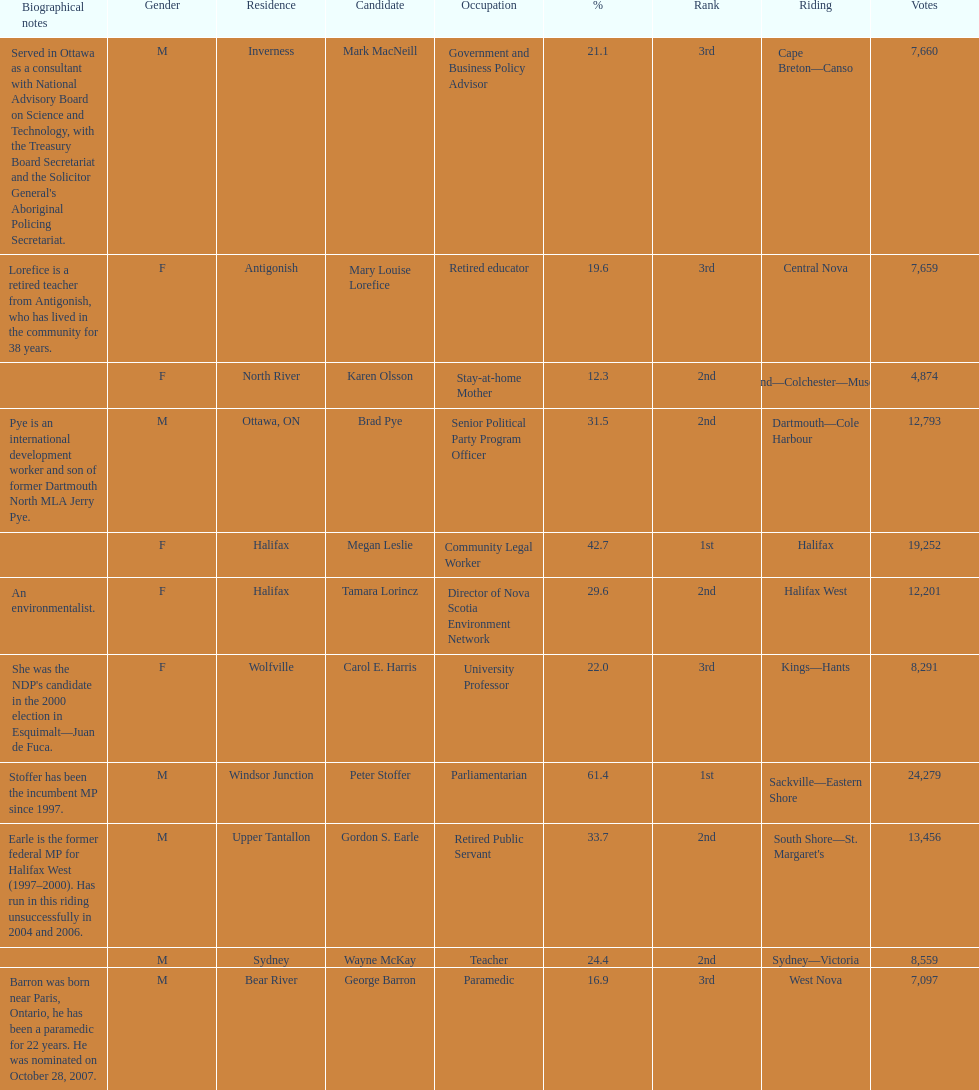How many of the candidates were females? 5. 